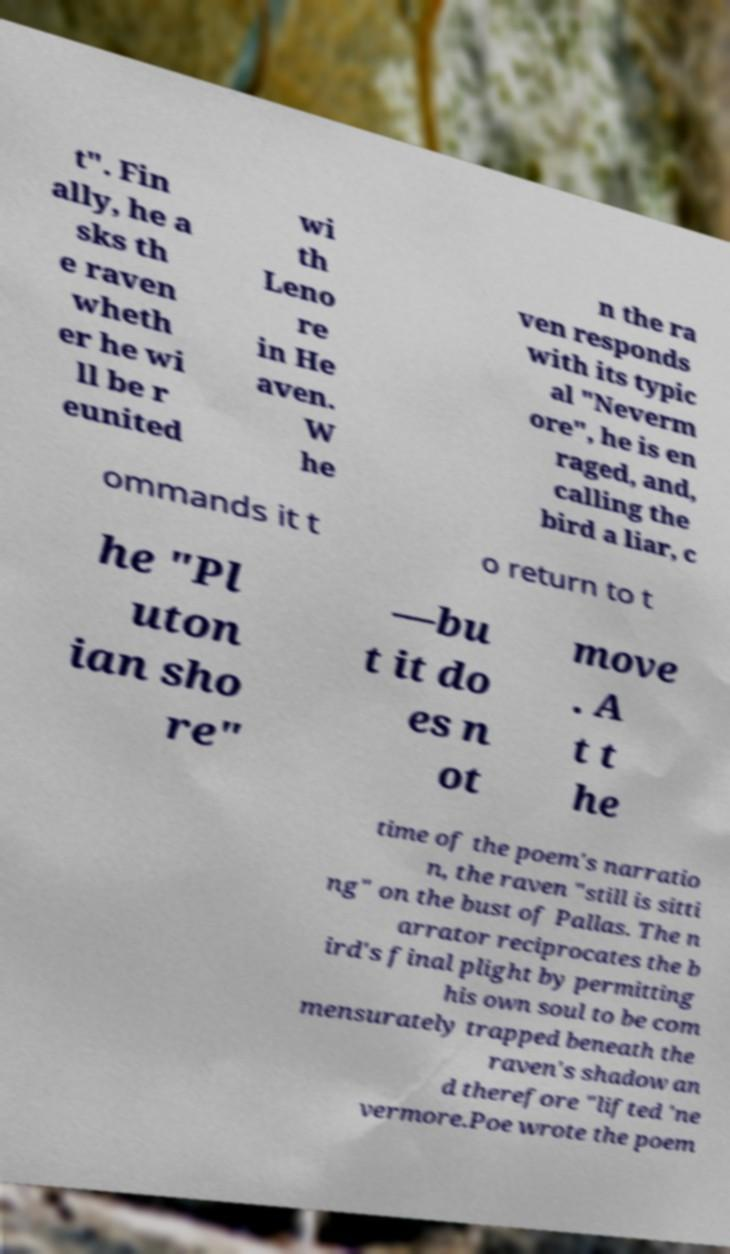Can you accurately transcribe the text from the provided image for me? t". Fin ally, he a sks th e raven wheth er he wi ll be r eunited wi th Leno re in He aven. W he n the ra ven responds with its typic al "Neverm ore", he is en raged, and, calling the bird a liar, c ommands it t o return to t he "Pl uton ian sho re" —bu t it do es n ot move . A t t he time of the poem's narratio n, the raven "still is sitti ng" on the bust of Pallas. The n arrator reciprocates the b ird's final plight by permitting his own soul to be com mensurately trapped beneath the raven's shadow an d therefore "lifted 'ne vermore.Poe wrote the poem 